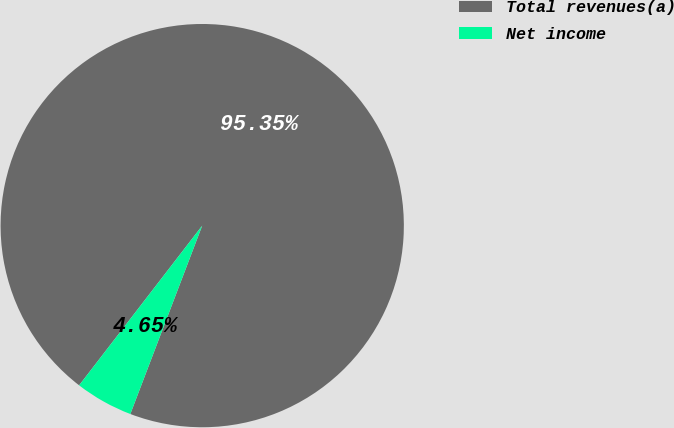<chart> <loc_0><loc_0><loc_500><loc_500><pie_chart><fcel>Total revenues(a)<fcel>Net income<nl><fcel>95.35%<fcel>4.65%<nl></chart> 